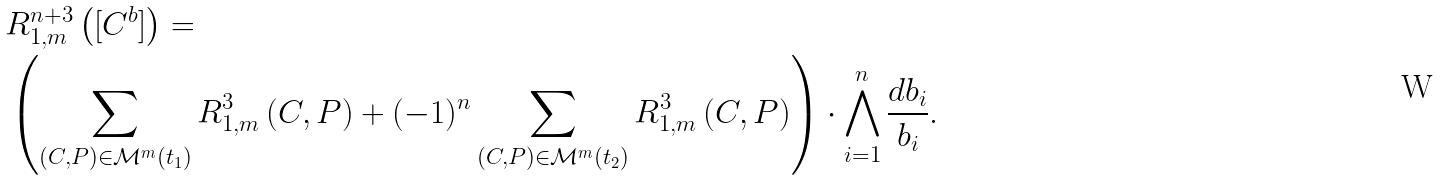<formula> <loc_0><loc_0><loc_500><loc_500>& R ^ { n + 3 } _ { 1 , m } \left ( [ C ^ { b } ] \right ) = \\ & \left ( \sum _ { ( C , P ) \in { \mathcal { M } } ^ { m } ( t _ { 1 } ) } R ^ { 3 } _ { 1 , m } \left ( C , P \right ) + ( - 1 ) ^ { n } \sum _ { ( C , P ) \in { \mathcal { M } } ^ { m } ( t _ { 2 } ) } R ^ { 3 } _ { 1 , m } \left ( C , P \right ) \right ) \cdot \bigwedge _ { i = 1 } ^ { n } \frac { d b _ { i } } { b _ { i } } .</formula> 